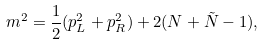<formula> <loc_0><loc_0><loc_500><loc_500>m ^ { 2 } = \frac { 1 } { 2 } ( p _ { L } ^ { 2 } + p _ { R } ^ { 2 } ) + 2 ( N + \tilde { N } - 1 ) ,</formula> 